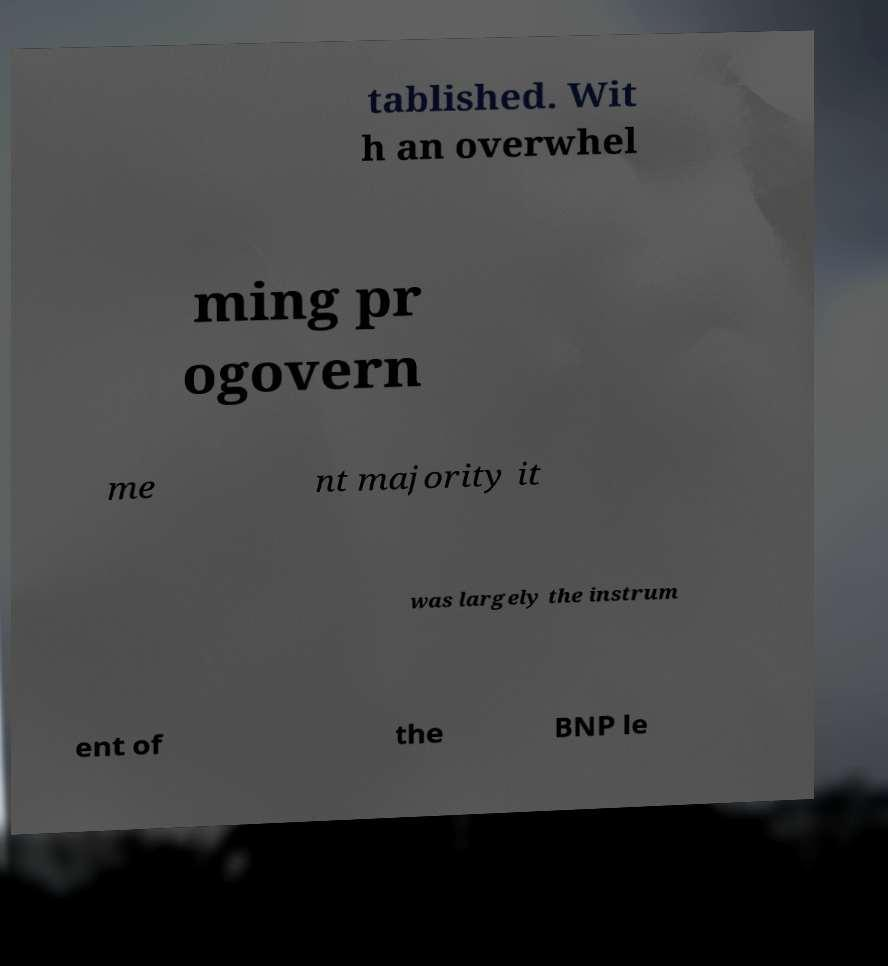I need the written content from this picture converted into text. Can you do that? tablished. Wit h an overwhel ming pr ogovern me nt majority it was largely the instrum ent of the BNP le 